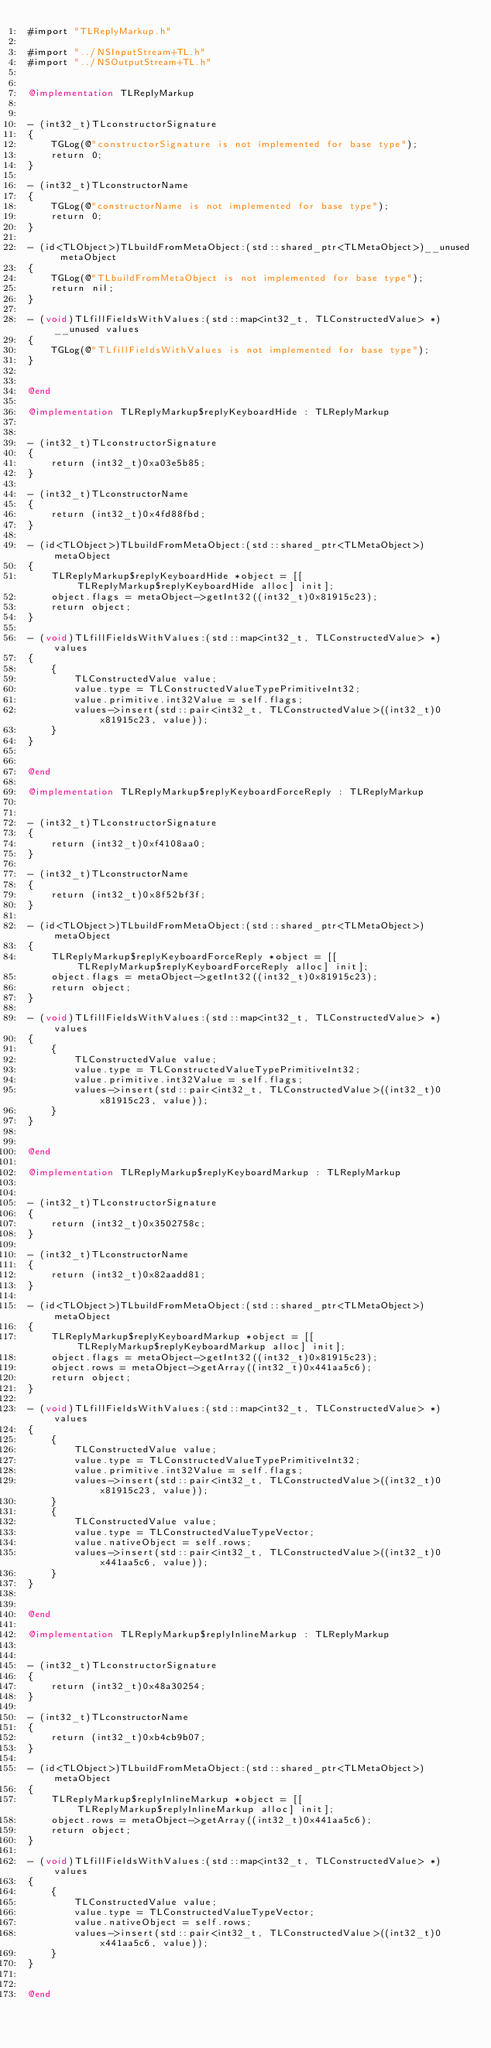<code> <loc_0><loc_0><loc_500><loc_500><_ObjectiveC_>#import "TLReplyMarkup.h"

#import "../NSInputStream+TL.h"
#import "../NSOutputStream+TL.h"


@implementation TLReplyMarkup


- (int32_t)TLconstructorSignature
{
    TGLog(@"constructorSignature is not implemented for base type");
    return 0;
}

- (int32_t)TLconstructorName
{
    TGLog(@"constructorName is not implemented for base type");
    return 0;
}

- (id<TLObject>)TLbuildFromMetaObject:(std::shared_ptr<TLMetaObject>)__unused metaObject
{
    TGLog(@"TLbuildFromMetaObject is not implemented for base type");
    return nil;
}

- (void)TLfillFieldsWithValues:(std::map<int32_t, TLConstructedValue> *)__unused values
{
    TGLog(@"TLfillFieldsWithValues is not implemented for base type");
}


@end

@implementation TLReplyMarkup$replyKeyboardHide : TLReplyMarkup


- (int32_t)TLconstructorSignature
{
    return (int32_t)0xa03e5b85;
}

- (int32_t)TLconstructorName
{
    return (int32_t)0x4fd88fbd;
}

- (id<TLObject>)TLbuildFromMetaObject:(std::shared_ptr<TLMetaObject>)metaObject
{
    TLReplyMarkup$replyKeyboardHide *object = [[TLReplyMarkup$replyKeyboardHide alloc] init];
    object.flags = metaObject->getInt32((int32_t)0x81915c23);
    return object;
}

- (void)TLfillFieldsWithValues:(std::map<int32_t, TLConstructedValue> *)values
{
    {
        TLConstructedValue value;
        value.type = TLConstructedValueTypePrimitiveInt32;
        value.primitive.int32Value = self.flags;
        values->insert(std::pair<int32_t, TLConstructedValue>((int32_t)0x81915c23, value));
    }
}


@end

@implementation TLReplyMarkup$replyKeyboardForceReply : TLReplyMarkup


- (int32_t)TLconstructorSignature
{
    return (int32_t)0xf4108aa0;
}

- (int32_t)TLconstructorName
{
    return (int32_t)0x8f52bf3f;
}

- (id<TLObject>)TLbuildFromMetaObject:(std::shared_ptr<TLMetaObject>)metaObject
{
    TLReplyMarkup$replyKeyboardForceReply *object = [[TLReplyMarkup$replyKeyboardForceReply alloc] init];
    object.flags = metaObject->getInt32((int32_t)0x81915c23);
    return object;
}

- (void)TLfillFieldsWithValues:(std::map<int32_t, TLConstructedValue> *)values
{
    {
        TLConstructedValue value;
        value.type = TLConstructedValueTypePrimitiveInt32;
        value.primitive.int32Value = self.flags;
        values->insert(std::pair<int32_t, TLConstructedValue>((int32_t)0x81915c23, value));
    }
}


@end

@implementation TLReplyMarkup$replyKeyboardMarkup : TLReplyMarkup


- (int32_t)TLconstructorSignature
{
    return (int32_t)0x3502758c;
}

- (int32_t)TLconstructorName
{
    return (int32_t)0x82aadd81;
}

- (id<TLObject>)TLbuildFromMetaObject:(std::shared_ptr<TLMetaObject>)metaObject
{
    TLReplyMarkup$replyKeyboardMarkup *object = [[TLReplyMarkup$replyKeyboardMarkup alloc] init];
    object.flags = metaObject->getInt32((int32_t)0x81915c23);
    object.rows = metaObject->getArray((int32_t)0x441aa5c6);
    return object;
}

- (void)TLfillFieldsWithValues:(std::map<int32_t, TLConstructedValue> *)values
{
    {
        TLConstructedValue value;
        value.type = TLConstructedValueTypePrimitiveInt32;
        value.primitive.int32Value = self.flags;
        values->insert(std::pair<int32_t, TLConstructedValue>((int32_t)0x81915c23, value));
    }
    {
        TLConstructedValue value;
        value.type = TLConstructedValueTypeVector;
        value.nativeObject = self.rows;
        values->insert(std::pair<int32_t, TLConstructedValue>((int32_t)0x441aa5c6, value));
    }
}


@end

@implementation TLReplyMarkup$replyInlineMarkup : TLReplyMarkup


- (int32_t)TLconstructorSignature
{
    return (int32_t)0x48a30254;
}

- (int32_t)TLconstructorName
{
    return (int32_t)0xb4cb9b07;
}

- (id<TLObject>)TLbuildFromMetaObject:(std::shared_ptr<TLMetaObject>)metaObject
{
    TLReplyMarkup$replyInlineMarkup *object = [[TLReplyMarkup$replyInlineMarkup alloc] init];
    object.rows = metaObject->getArray((int32_t)0x441aa5c6);
    return object;
}

- (void)TLfillFieldsWithValues:(std::map<int32_t, TLConstructedValue> *)values
{
    {
        TLConstructedValue value;
        value.type = TLConstructedValueTypeVector;
        value.nativeObject = self.rows;
        values->insert(std::pair<int32_t, TLConstructedValue>((int32_t)0x441aa5c6, value));
    }
}


@end

</code> 